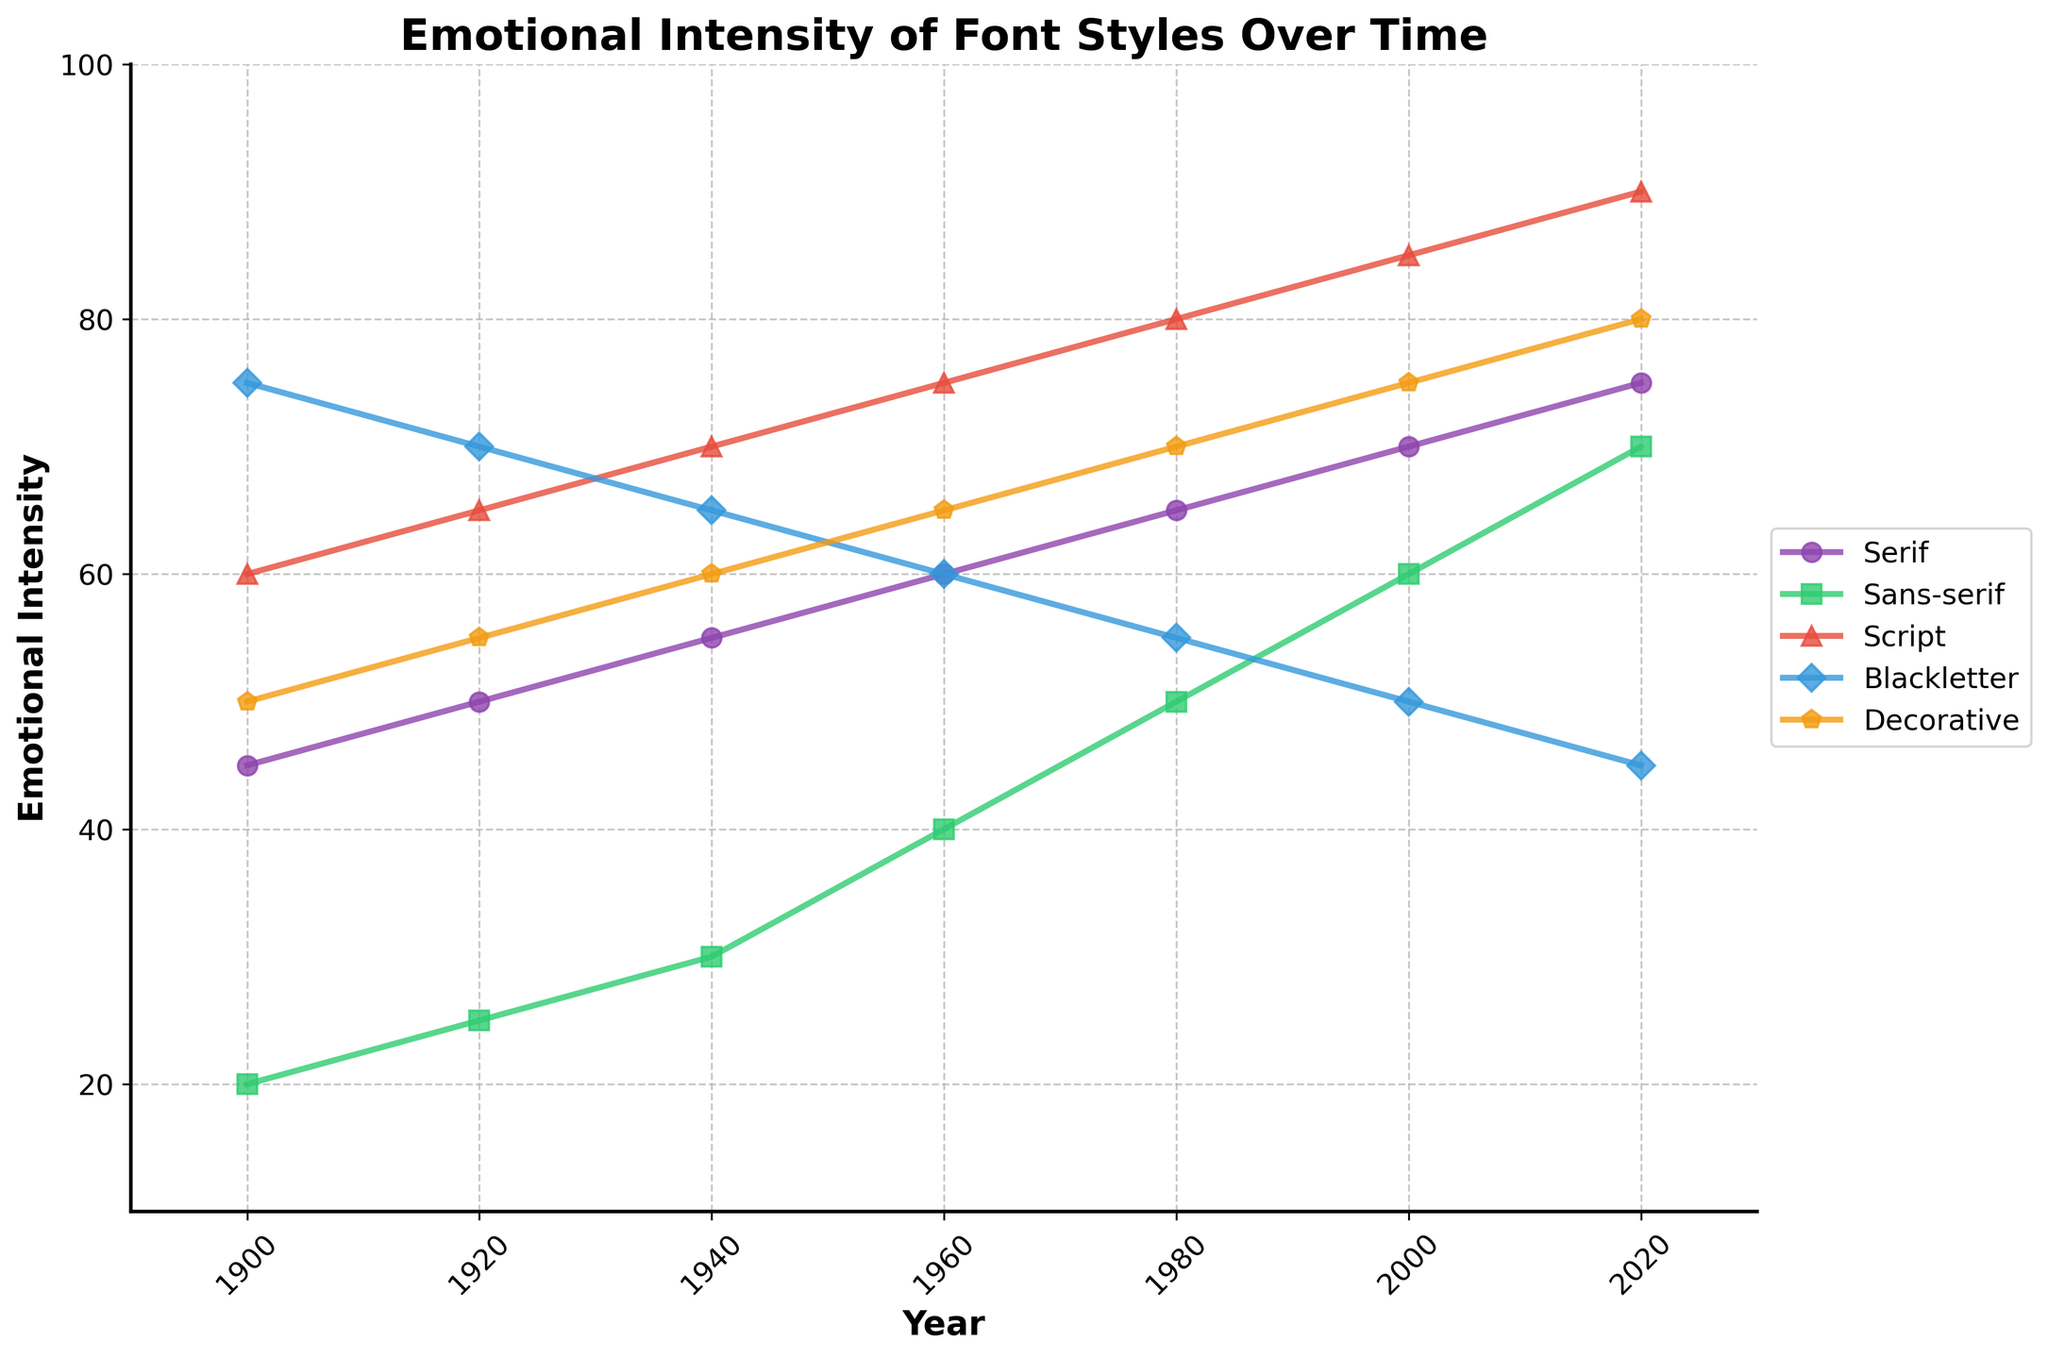What year did Script fonts reach their highest emotional intensity? Script fonts reached their highest emotional intensity in the year 2020, as shown by the highest point on the Script line.
Answer: 2020 Which font style had the highest emotional intensity in 1940? In 1940, the Script font had the highest emotional intensity. This can be seen by comparing the peaks of all the lines in that year.
Answer: Script Comparing Serif and Sans-serif, which font style saw a higher increase in emotional intensity between 2000 and 2020? Serif increased from 70 in 2000 to 75 in 2020, which is an increase of 5. Sans-serif increased from 60 in 2000 to 70 in 2020, which is an increase of 10.
Answer: Sans-serif Between 1960 and 1980, did Blackletter emotional intensity increase or decrease, and by how much? Blackletter decreased from 60 in 1960 to 55 in 1980, a difference of 5.
Answer: Decreased by 5 What is the average emotional intensity of Script fonts over the time period shown? The emotional intensity values for Script are 60, 65, 70, 75, 80, 85, and 90. Summing these gives 525. Dividing by the number of data points (7) gives an average of 75.
Answer: 75 Compare the emotional intensity of Decorative fonts in 1900 and 2020. What is the difference? In 1900, Decorative fonts had an emotional intensity of 50. In 2020, it was 80. The difference is 80 - 50 = 30.
Answer: 30 Which font style showed a consistent increase in emotional intensity from 1900 to 2020? By observing the upward trend in the plotted lines, the Serif and Sans-serif font styles show a consistent increase in emotional intensity from 1900 to 2020.
Answer: Serif and Sans-serif Among all the font styles, which one had the lowest emotional intensity in the year 2000? In the year 2000, Blackletter had the lowest emotional intensity of 50.
Answer: Blackletter What is the difference in emotional intensity between the highest and lowest points in the year 1960? In 1960, the highest intensity is Script with 75 and the lowest is Blackletter with 60. The difference is 75 - 60 = 15.
Answer: 15 What is the trend observed in the emotional intensity of Serif fonts from 1900 to 2020? The emotional intensity of Serif fonts shows a steady increase from 45 in 1900 to 75 in 2020, indicating a gradual rise over time.
Answer: Gradual increase 